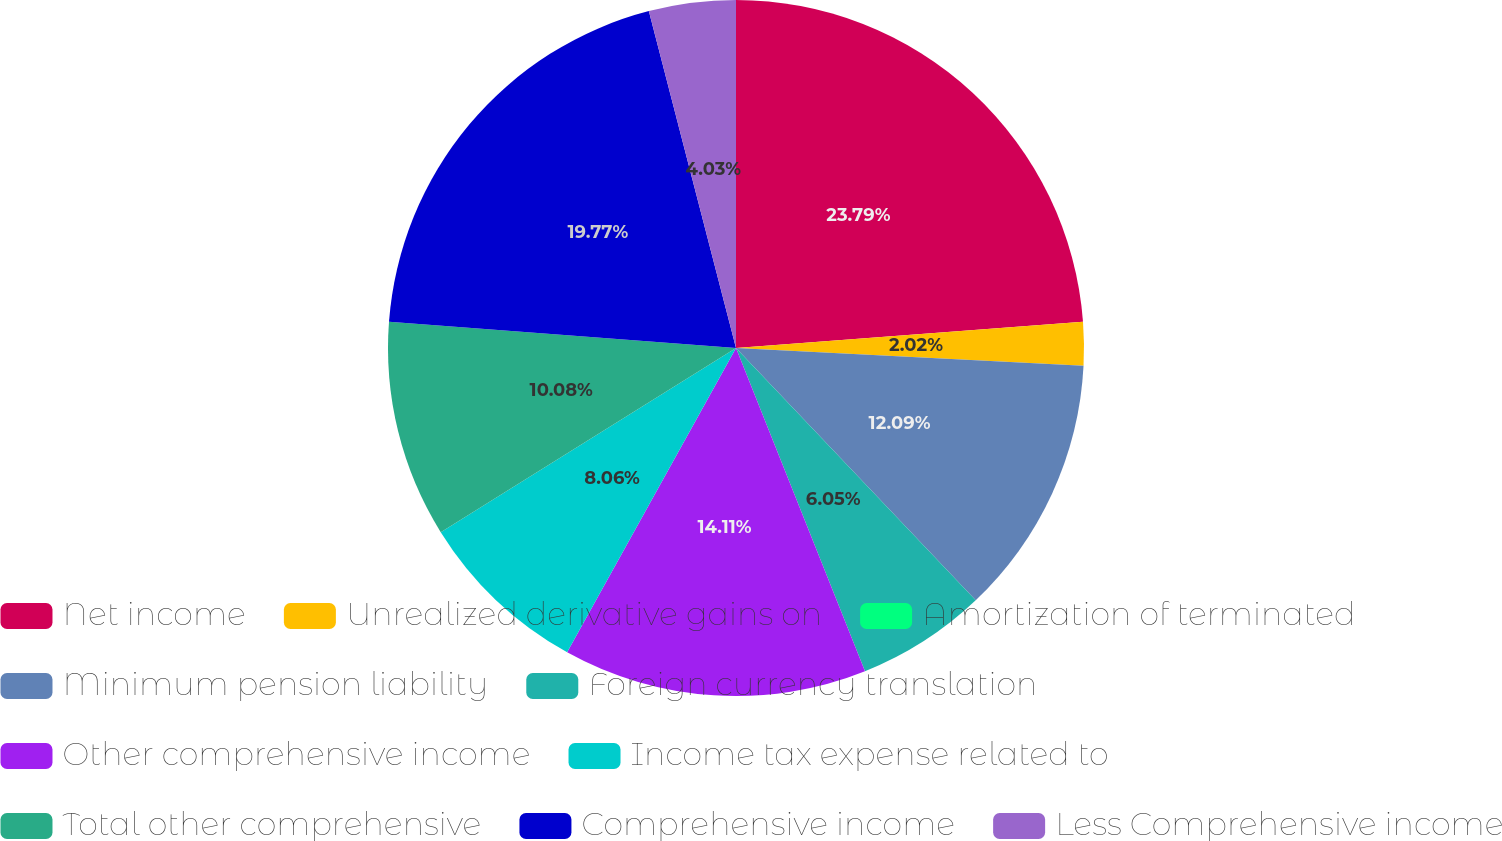Convert chart. <chart><loc_0><loc_0><loc_500><loc_500><pie_chart><fcel>Net income<fcel>Unrealized derivative gains on<fcel>Amortization of terminated<fcel>Minimum pension liability<fcel>Foreign currency translation<fcel>Other comprehensive income<fcel>Income tax expense related to<fcel>Total other comprehensive<fcel>Comprehensive income<fcel>Less Comprehensive income<nl><fcel>23.8%<fcel>2.02%<fcel>0.0%<fcel>12.09%<fcel>6.05%<fcel>14.11%<fcel>8.06%<fcel>10.08%<fcel>19.77%<fcel>4.03%<nl></chart> 